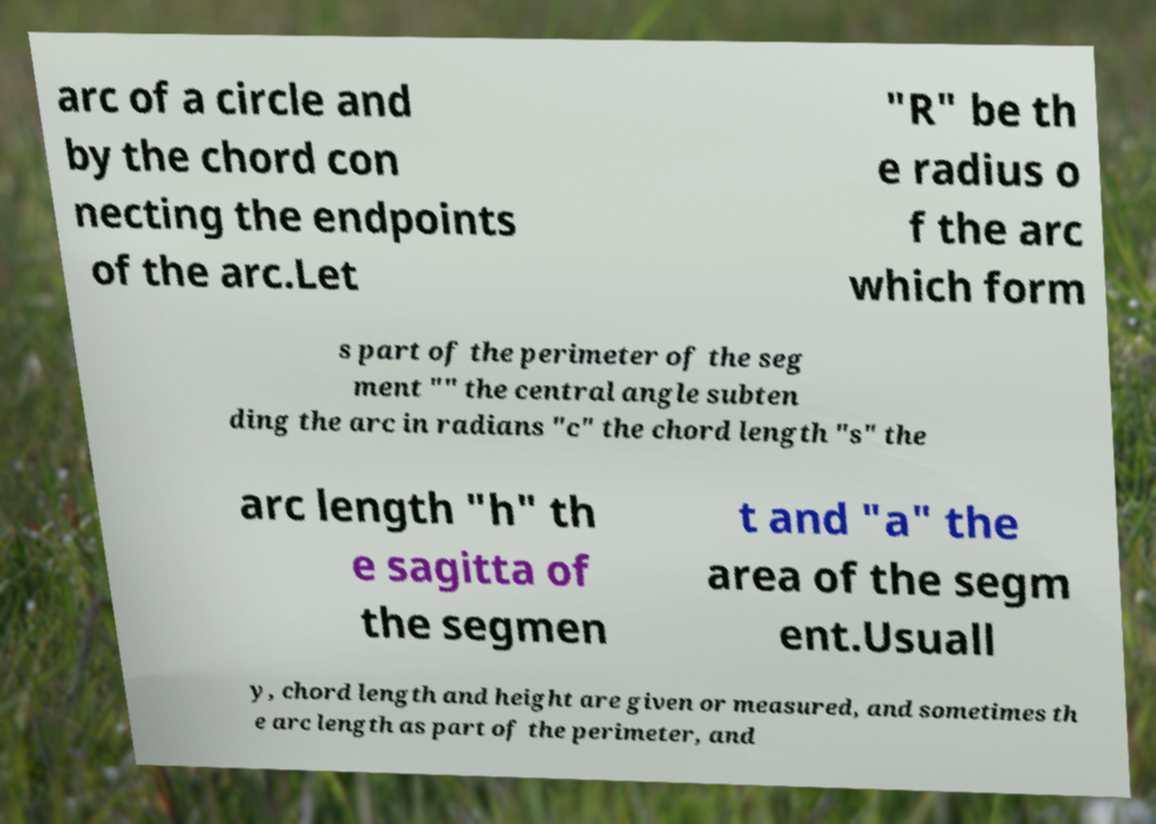Can you accurately transcribe the text from the provided image for me? arc of a circle and by the chord con necting the endpoints of the arc.Let "R" be th e radius o f the arc which form s part of the perimeter of the seg ment "" the central angle subten ding the arc in radians "c" the chord length "s" the arc length "h" th e sagitta of the segmen t and "a" the area of the segm ent.Usuall y, chord length and height are given or measured, and sometimes th e arc length as part of the perimeter, and 